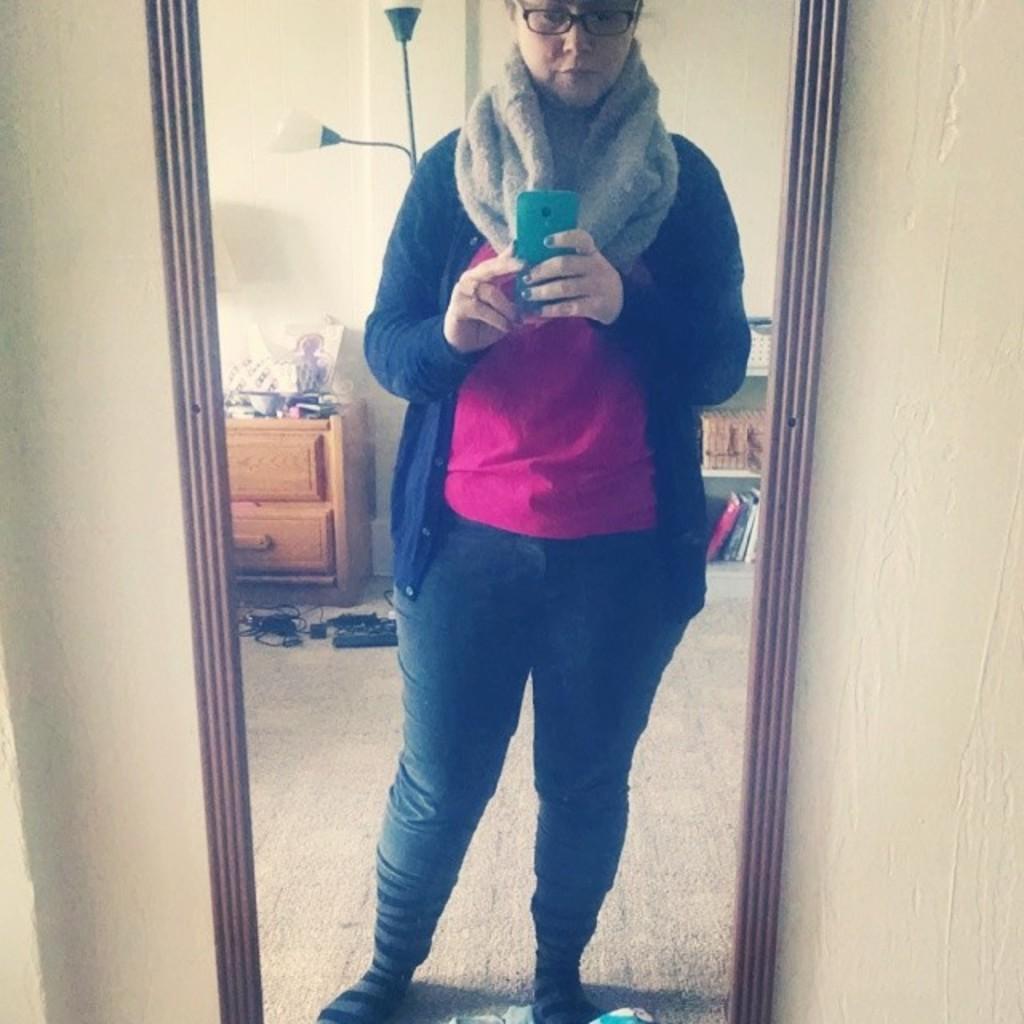Can you describe this image briefly? In the picture we can see a woman standing near the entrance of the house and holding a mobile phone and behind her in the house we can see a table with some things are placed on it and on the floor we can see some wires are placed. 